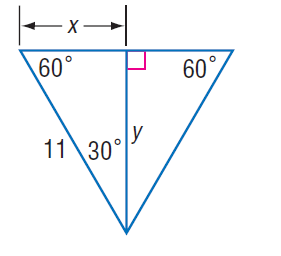Answer the mathemtical geometry problem and directly provide the correct option letter.
Question: Find x.
Choices: A: 5.5 B: 5.5 \sqrt { 2 } C: 11 D: 11 \sqrt { 2 } A 